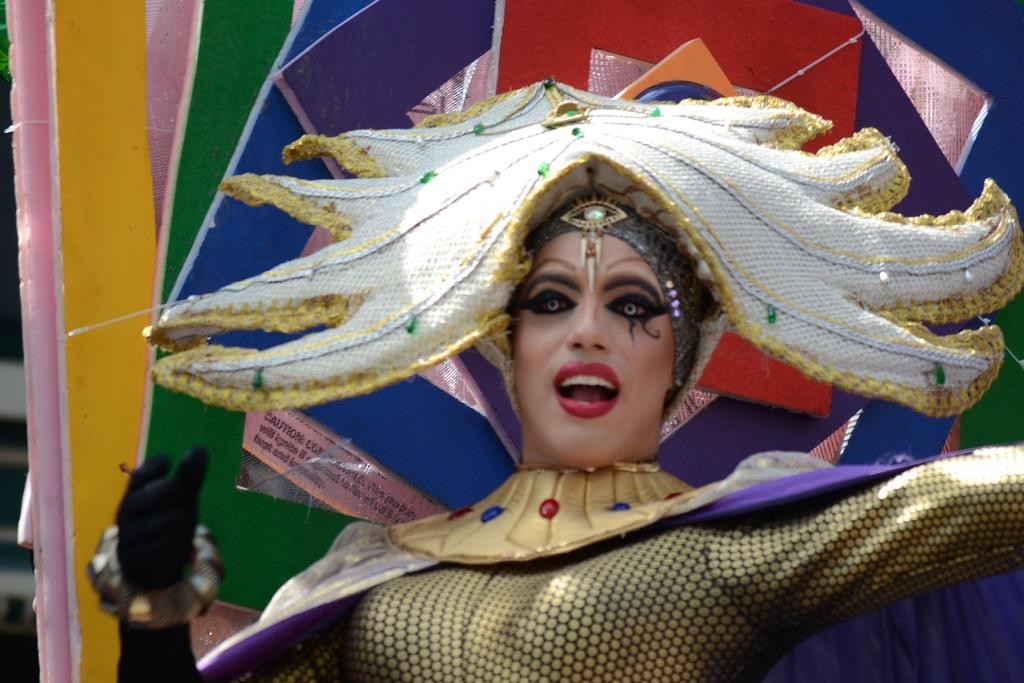Who is the main subject in the image? There is a woman in the image. What is the woman doing in the image? The woman is standing in the image. What is the woman wearing in the image? The woman is wearing a costume in the image. How would you describe the background of the image? The background of the image is colorful. How many feathers can be seen on the woman's costume in the image? There is no mention of feathers on the woman's costume in the image, so it cannot be determined from the facts provided. 